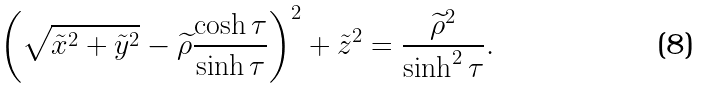<formula> <loc_0><loc_0><loc_500><loc_500>\left ( \sqrt { \tilde { x } ^ { 2 } + \tilde { y } ^ { 2 } } - \widetilde { \rho } \frac { \cosh \tau } { \sinh \tau } \right ) ^ { 2 } + \tilde { z } ^ { 2 } = \frac { \widetilde { \rho } ^ { 2 } } { \sinh ^ { 2 } \tau } .</formula> 